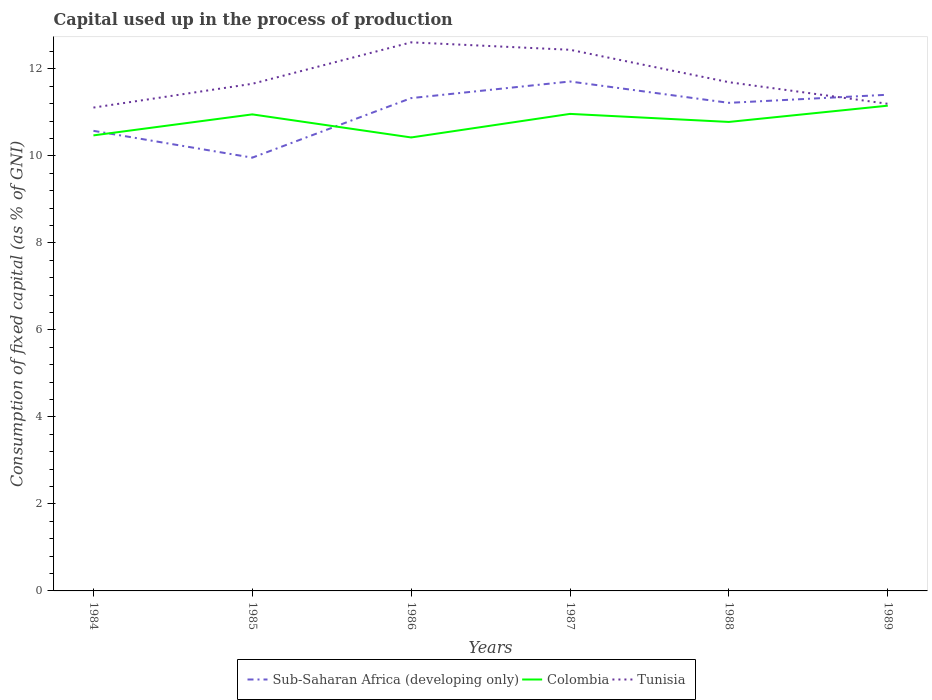Does the line corresponding to Tunisia intersect with the line corresponding to Sub-Saharan Africa (developing only)?
Offer a very short reply. Yes. Across all years, what is the maximum capital used up in the process of production in Tunisia?
Give a very brief answer. 11.11. In which year was the capital used up in the process of production in Colombia maximum?
Offer a very short reply. 1986. What is the total capital used up in the process of production in Colombia in the graph?
Keep it short and to the point. -0.19. What is the difference between the highest and the second highest capital used up in the process of production in Sub-Saharan Africa (developing only)?
Give a very brief answer. 1.75. What is the difference between the highest and the lowest capital used up in the process of production in Sub-Saharan Africa (developing only)?
Your answer should be very brief. 4. Is the capital used up in the process of production in Tunisia strictly greater than the capital used up in the process of production in Colombia over the years?
Offer a terse response. No. Are the values on the major ticks of Y-axis written in scientific E-notation?
Provide a short and direct response. No. What is the title of the graph?
Your answer should be compact. Capital used up in the process of production. What is the label or title of the X-axis?
Offer a very short reply. Years. What is the label or title of the Y-axis?
Offer a very short reply. Consumption of fixed capital (as % of GNI). What is the Consumption of fixed capital (as % of GNI) of Sub-Saharan Africa (developing only) in 1984?
Offer a very short reply. 10.58. What is the Consumption of fixed capital (as % of GNI) in Colombia in 1984?
Offer a very short reply. 10.47. What is the Consumption of fixed capital (as % of GNI) in Tunisia in 1984?
Make the answer very short. 11.11. What is the Consumption of fixed capital (as % of GNI) of Sub-Saharan Africa (developing only) in 1985?
Make the answer very short. 9.96. What is the Consumption of fixed capital (as % of GNI) in Colombia in 1985?
Offer a terse response. 10.96. What is the Consumption of fixed capital (as % of GNI) in Tunisia in 1985?
Keep it short and to the point. 11.66. What is the Consumption of fixed capital (as % of GNI) of Sub-Saharan Africa (developing only) in 1986?
Your answer should be compact. 11.33. What is the Consumption of fixed capital (as % of GNI) in Colombia in 1986?
Your answer should be very brief. 10.43. What is the Consumption of fixed capital (as % of GNI) in Tunisia in 1986?
Ensure brevity in your answer.  12.61. What is the Consumption of fixed capital (as % of GNI) in Sub-Saharan Africa (developing only) in 1987?
Give a very brief answer. 11.71. What is the Consumption of fixed capital (as % of GNI) of Colombia in 1987?
Your answer should be compact. 10.97. What is the Consumption of fixed capital (as % of GNI) in Tunisia in 1987?
Provide a succinct answer. 12.44. What is the Consumption of fixed capital (as % of GNI) in Sub-Saharan Africa (developing only) in 1988?
Your answer should be compact. 11.22. What is the Consumption of fixed capital (as % of GNI) in Colombia in 1988?
Provide a short and direct response. 10.78. What is the Consumption of fixed capital (as % of GNI) in Tunisia in 1988?
Provide a short and direct response. 11.7. What is the Consumption of fixed capital (as % of GNI) in Sub-Saharan Africa (developing only) in 1989?
Your response must be concise. 11.41. What is the Consumption of fixed capital (as % of GNI) in Colombia in 1989?
Keep it short and to the point. 11.16. What is the Consumption of fixed capital (as % of GNI) of Tunisia in 1989?
Ensure brevity in your answer.  11.2. Across all years, what is the maximum Consumption of fixed capital (as % of GNI) in Sub-Saharan Africa (developing only)?
Your answer should be compact. 11.71. Across all years, what is the maximum Consumption of fixed capital (as % of GNI) in Colombia?
Your answer should be compact. 11.16. Across all years, what is the maximum Consumption of fixed capital (as % of GNI) of Tunisia?
Your answer should be very brief. 12.61. Across all years, what is the minimum Consumption of fixed capital (as % of GNI) in Sub-Saharan Africa (developing only)?
Your answer should be compact. 9.96. Across all years, what is the minimum Consumption of fixed capital (as % of GNI) in Colombia?
Provide a succinct answer. 10.43. Across all years, what is the minimum Consumption of fixed capital (as % of GNI) of Tunisia?
Offer a very short reply. 11.11. What is the total Consumption of fixed capital (as % of GNI) in Sub-Saharan Africa (developing only) in the graph?
Offer a terse response. 66.21. What is the total Consumption of fixed capital (as % of GNI) in Colombia in the graph?
Your answer should be very brief. 64.76. What is the total Consumption of fixed capital (as % of GNI) in Tunisia in the graph?
Make the answer very short. 70.72. What is the difference between the Consumption of fixed capital (as % of GNI) of Sub-Saharan Africa (developing only) in 1984 and that in 1985?
Your answer should be compact. 0.62. What is the difference between the Consumption of fixed capital (as % of GNI) in Colombia in 1984 and that in 1985?
Provide a short and direct response. -0.48. What is the difference between the Consumption of fixed capital (as % of GNI) of Tunisia in 1984 and that in 1985?
Your answer should be very brief. -0.55. What is the difference between the Consumption of fixed capital (as % of GNI) of Sub-Saharan Africa (developing only) in 1984 and that in 1986?
Ensure brevity in your answer.  -0.75. What is the difference between the Consumption of fixed capital (as % of GNI) in Colombia in 1984 and that in 1986?
Your answer should be very brief. 0.05. What is the difference between the Consumption of fixed capital (as % of GNI) of Tunisia in 1984 and that in 1986?
Make the answer very short. -1.5. What is the difference between the Consumption of fixed capital (as % of GNI) of Sub-Saharan Africa (developing only) in 1984 and that in 1987?
Ensure brevity in your answer.  -1.13. What is the difference between the Consumption of fixed capital (as % of GNI) in Colombia in 1984 and that in 1987?
Your response must be concise. -0.49. What is the difference between the Consumption of fixed capital (as % of GNI) of Tunisia in 1984 and that in 1987?
Offer a terse response. -1.33. What is the difference between the Consumption of fixed capital (as % of GNI) of Sub-Saharan Africa (developing only) in 1984 and that in 1988?
Offer a terse response. -0.64. What is the difference between the Consumption of fixed capital (as % of GNI) of Colombia in 1984 and that in 1988?
Provide a short and direct response. -0.31. What is the difference between the Consumption of fixed capital (as % of GNI) in Tunisia in 1984 and that in 1988?
Your response must be concise. -0.58. What is the difference between the Consumption of fixed capital (as % of GNI) of Sub-Saharan Africa (developing only) in 1984 and that in 1989?
Give a very brief answer. -0.83. What is the difference between the Consumption of fixed capital (as % of GNI) of Colombia in 1984 and that in 1989?
Give a very brief answer. -0.68. What is the difference between the Consumption of fixed capital (as % of GNI) in Tunisia in 1984 and that in 1989?
Make the answer very short. -0.09. What is the difference between the Consumption of fixed capital (as % of GNI) in Sub-Saharan Africa (developing only) in 1985 and that in 1986?
Your answer should be very brief. -1.37. What is the difference between the Consumption of fixed capital (as % of GNI) of Colombia in 1985 and that in 1986?
Ensure brevity in your answer.  0.53. What is the difference between the Consumption of fixed capital (as % of GNI) in Tunisia in 1985 and that in 1986?
Provide a short and direct response. -0.95. What is the difference between the Consumption of fixed capital (as % of GNI) in Sub-Saharan Africa (developing only) in 1985 and that in 1987?
Ensure brevity in your answer.  -1.75. What is the difference between the Consumption of fixed capital (as % of GNI) in Colombia in 1985 and that in 1987?
Give a very brief answer. -0.01. What is the difference between the Consumption of fixed capital (as % of GNI) in Tunisia in 1985 and that in 1987?
Offer a very short reply. -0.78. What is the difference between the Consumption of fixed capital (as % of GNI) of Sub-Saharan Africa (developing only) in 1985 and that in 1988?
Give a very brief answer. -1.26. What is the difference between the Consumption of fixed capital (as % of GNI) of Colombia in 1985 and that in 1988?
Your answer should be compact. 0.17. What is the difference between the Consumption of fixed capital (as % of GNI) of Tunisia in 1985 and that in 1988?
Provide a succinct answer. -0.04. What is the difference between the Consumption of fixed capital (as % of GNI) in Sub-Saharan Africa (developing only) in 1985 and that in 1989?
Make the answer very short. -1.45. What is the difference between the Consumption of fixed capital (as % of GNI) of Colombia in 1985 and that in 1989?
Give a very brief answer. -0.2. What is the difference between the Consumption of fixed capital (as % of GNI) of Tunisia in 1985 and that in 1989?
Your answer should be compact. 0.46. What is the difference between the Consumption of fixed capital (as % of GNI) in Sub-Saharan Africa (developing only) in 1986 and that in 1987?
Provide a short and direct response. -0.38. What is the difference between the Consumption of fixed capital (as % of GNI) in Colombia in 1986 and that in 1987?
Provide a succinct answer. -0.54. What is the difference between the Consumption of fixed capital (as % of GNI) of Tunisia in 1986 and that in 1987?
Offer a very short reply. 0.17. What is the difference between the Consumption of fixed capital (as % of GNI) in Sub-Saharan Africa (developing only) in 1986 and that in 1988?
Offer a very short reply. 0.11. What is the difference between the Consumption of fixed capital (as % of GNI) in Colombia in 1986 and that in 1988?
Give a very brief answer. -0.36. What is the difference between the Consumption of fixed capital (as % of GNI) in Tunisia in 1986 and that in 1988?
Offer a very short reply. 0.92. What is the difference between the Consumption of fixed capital (as % of GNI) of Sub-Saharan Africa (developing only) in 1986 and that in 1989?
Your answer should be compact. -0.08. What is the difference between the Consumption of fixed capital (as % of GNI) in Colombia in 1986 and that in 1989?
Offer a very short reply. -0.73. What is the difference between the Consumption of fixed capital (as % of GNI) in Tunisia in 1986 and that in 1989?
Provide a succinct answer. 1.41. What is the difference between the Consumption of fixed capital (as % of GNI) of Sub-Saharan Africa (developing only) in 1987 and that in 1988?
Give a very brief answer. 0.49. What is the difference between the Consumption of fixed capital (as % of GNI) in Colombia in 1987 and that in 1988?
Your response must be concise. 0.18. What is the difference between the Consumption of fixed capital (as % of GNI) of Tunisia in 1987 and that in 1988?
Provide a succinct answer. 0.75. What is the difference between the Consumption of fixed capital (as % of GNI) in Sub-Saharan Africa (developing only) in 1987 and that in 1989?
Provide a short and direct response. 0.3. What is the difference between the Consumption of fixed capital (as % of GNI) of Colombia in 1987 and that in 1989?
Offer a very short reply. -0.19. What is the difference between the Consumption of fixed capital (as % of GNI) in Tunisia in 1987 and that in 1989?
Your response must be concise. 1.24. What is the difference between the Consumption of fixed capital (as % of GNI) in Sub-Saharan Africa (developing only) in 1988 and that in 1989?
Ensure brevity in your answer.  -0.19. What is the difference between the Consumption of fixed capital (as % of GNI) of Colombia in 1988 and that in 1989?
Offer a very short reply. -0.37. What is the difference between the Consumption of fixed capital (as % of GNI) in Tunisia in 1988 and that in 1989?
Make the answer very short. 0.5. What is the difference between the Consumption of fixed capital (as % of GNI) of Sub-Saharan Africa (developing only) in 1984 and the Consumption of fixed capital (as % of GNI) of Colombia in 1985?
Your answer should be very brief. -0.38. What is the difference between the Consumption of fixed capital (as % of GNI) in Sub-Saharan Africa (developing only) in 1984 and the Consumption of fixed capital (as % of GNI) in Tunisia in 1985?
Your answer should be compact. -1.08. What is the difference between the Consumption of fixed capital (as % of GNI) in Colombia in 1984 and the Consumption of fixed capital (as % of GNI) in Tunisia in 1985?
Make the answer very short. -1.19. What is the difference between the Consumption of fixed capital (as % of GNI) in Sub-Saharan Africa (developing only) in 1984 and the Consumption of fixed capital (as % of GNI) in Colombia in 1986?
Make the answer very short. 0.15. What is the difference between the Consumption of fixed capital (as % of GNI) of Sub-Saharan Africa (developing only) in 1984 and the Consumption of fixed capital (as % of GNI) of Tunisia in 1986?
Provide a succinct answer. -2.03. What is the difference between the Consumption of fixed capital (as % of GNI) in Colombia in 1984 and the Consumption of fixed capital (as % of GNI) in Tunisia in 1986?
Make the answer very short. -2.14. What is the difference between the Consumption of fixed capital (as % of GNI) in Sub-Saharan Africa (developing only) in 1984 and the Consumption of fixed capital (as % of GNI) in Colombia in 1987?
Your response must be concise. -0.39. What is the difference between the Consumption of fixed capital (as % of GNI) of Sub-Saharan Africa (developing only) in 1984 and the Consumption of fixed capital (as % of GNI) of Tunisia in 1987?
Keep it short and to the point. -1.86. What is the difference between the Consumption of fixed capital (as % of GNI) of Colombia in 1984 and the Consumption of fixed capital (as % of GNI) of Tunisia in 1987?
Make the answer very short. -1.97. What is the difference between the Consumption of fixed capital (as % of GNI) of Sub-Saharan Africa (developing only) in 1984 and the Consumption of fixed capital (as % of GNI) of Colombia in 1988?
Provide a succinct answer. -0.2. What is the difference between the Consumption of fixed capital (as % of GNI) of Sub-Saharan Africa (developing only) in 1984 and the Consumption of fixed capital (as % of GNI) of Tunisia in 1988?
Make the answer very short. -1.12. What is the difference between the Consumption of fixed capital (as % of GNI) in Colombia in 1984 and the Consumption of fixed capital (as % of GNI) in Tunisia in 1988?
Ensure brevity in your answer.  -1.22. What is the difference between the Consumption of fixed capital (as % of GNI) of Sub-Saharan Africa (developing only) in 1984 and the Consumption of fixed capital (as % of GNI) of Colombia in 1989?
Ensure brevity in your answer.  -0.58. What is the difference between the Consumption of fixed capital (as % of GNI) of Sub-Saharan Africa (developing only) in 1984 and the Consumption of fixed capital (as % of GNI) of Tunisia in 1989?
Offer a terse response. -0.62. What is the difference between the Consumption of fixed capital (as % of GNI) in Colombia in 1984 and the Consumption of fixed capital (as % of GNI) in Tunisia in 1989?
Offer a terse response. -0.73. What is the difference between the Consumption of fixed capital (as % of GNI) of Sub-Saharan Africa (developing only) in 1985 and the Consumption of fixed capital (as % of GNI) of Colombia in 1986?
Offer a very short reply. -0.46. What is the difference between the Consumption of fixed capital (as % of GNI) of Sub-Saharan Africa (developing only) in 1985 and the Consumption of fixed capital (as % of GNI) of Tunisia in 1986?
Make the answer very short. -2.65. What is the difference between the Consumption of fixed capital (as % of GNI) in Colombia in 1985 and the Consumption of fixed capital (as % of GNI) in Tunisia in 1986?
Your response must be concise. -1.66. What is the difference between the Consumption of fixed capital (as % of GNI) in Sub-Saharan Africa (developing only) in 1985 and the Consumption of fixed capital (as % of GNI) in Colombia in 1987?
Provide a short and direct response. -1.01. What is the difference between the Consumption of fixed capital (as % of GNI) of Sub-Saharan Africa (developing only) in 1985 and the Consumption of fixed capital (as % of GNI) of Tunisia in 1987?
Make the answer very short. -2.48. What is the difference between the Consumption of fixed capital (as % of GNI) in Colombia in 1985 and the Consumption of fixed capital (as % of GNI) in Tunisia in 1987?
Offer a terse response. -1.49. What is the difference between the Consumption of fixed capital (as % of GNI) in Sub-Saharan Africa (developing only) in 1985 and the Consumption of fixed capital (as % of GNI) in Colombia in 1988?
Offer a terse response. -0.82. What is the difference between the Consumption of fixed capital (as % of GNI) in Sub-Saharan Africa (developing only) in 1985 and the Consumption of fixed capital (as % of GNI) in Tunisia in 1988?
Give a very brief answer. -1.73. What is the difference between the Consumption of fixed capital (as % of GNI) of Colombia in 1985 and the Consumption of fixed capital (as % of GNI) of Tunisia in 1988?
Your answer should be compact. -0.74. What is the difference between the Consumption of fixed capital (as % of GNI) of Sub-Saharan Africa (developing only) in 1985 and the Consumption of fixed capital (as % of GNI) of Colombia in 1989?
Your response must be concise. -1.2. What is the difference between the Consumption of fixed capital (as % of GNI) in Sub-Saharan Africa (developing only) in 1985 and the Consumption of fixed capital (as % of GNI) in Tunisia in 1989?
Your answer should be very brief. -1.24. What is the difference between the Consumption of fixed capital (as % of GNI) in Colombia in 1985 and the Consumption of fixed capital (as % of GNI) in Tunisia in 1989?
Your response must be concise. -0.24. What is the difference between the Consumption of fixed capital (as % of GNI) of Sub-Saharan Africa (developing only) in 1986 and the Consumption of fixed capital (as % of GNI) of Colombia in 1987?
Give a very brief answer. 0.36. What is the difference between the Consumption of fixed capital (as % of GNI) in Sub-Saharan Africa (developing only) in 1986 and the Consumption of fixed capital (as % of GNI) in Tunisia in 1987?
Provide a short and direct response. -1.11. What is the difference between the Consumption of fixed capital (as % of GNI) in Colombia in 1986 and the Consumption of fixed capital (as % of GNI) in Tunisia in 1987?
Your answer should be compact. -2.02. What is the difference between the Consumption of fixed capital (as % of GNI) in Sub-Saharan Africa (developing only) in 1986 and the Consumption of fixed capital (as % of GNI) in Colombia in 1988?
Make the answer very short. 0.55. What is the difference between the Consumption of fixed capital (as % of GNI) of Sub-Saharan Africa (developing only) in 1986 and the Consumption of fixed capital (as % of GNI) of Tunisia in 1988?
Give a very brief answer. -0.37. What is the difference between the Consumption of fixed capital (as % of GNI) in Colombia in 1986 and the Consumption of fixed capital (as % of GNI) in Tunisia in 1988?
Provide a short and direct response. -1.27. What is the difference between the Consumption of fixed capital (as % of GNI) of Sub-Saharan Africa (developing only) in 1986 and the Consumption of fixed capital (as % of GNI) of Colombia in 1989?
Give a very brief answer. 0.17. What is the difference between the Consumption of fixed capital (as % of GNI) of Sub-Saharan Africa (developing only) in 1986 and the Consumption of fixed capital (as % of GNI) of Tunisia in 1989?
Your response must be concise. 0.13. What is the difference between the Consumption of fixed capital (as % of GNI) of Colombia in 1986 and the Consumption of fixed capital (as % of GNI) of Tunisia in 1989?
Keep it short and to the point. -0.77. What is the difference between the Consumption of fixed capital (as % of GNI) of Sub-Saharan Africa (developing only) in 1987 and the Consumption of fixed capital (as % of GNI) of Colombia in 1988?
Your response must be concise. 0.93. What is the difference between the Consumption of fixed capital (as % of GNI) in Sub-Saharan Africa (developing only) in 1987 and the Consumption of fixed capital (as % of GNI) in Tunisia in 1988?
Your answer should be compact. 0.02. What is the difference between the Consumption of fixed capital (as % of GNI) of Colombia in 1987 and the Consumption of fixed capital (as % of GNI) of Tunisia in 1988?
Give a very brief answer. -0.73. What is the difference between the Consumption of fixed capital (as % of GNI) in Sub-Saharan Africa (developing only) in 1987 and the Consumption of fixed capital (as % of GNI) in Colombia in 1989?
Offer a terse response. 0.56. What is the difference between the Consumption of fixed capital (as % of GNI) of Sub-Saharan Africa (developing only) in 1987 and the Consumption of fixed capital (as % of GNI) of Tunisia in 1989?
Your answer should be very brief. 0.51. What is the difference between the Consumption of fixed capital (as % of GNI) in Colombia in 1987 and the Consumption of fixed capital (as % of GNI) in Tunisia in 1989?
Provide a short and direct response. -0.23. What is the difference between the Consumption of fixed capital (as % of GNI) of Sub-Saharan Africa (developing only) in 1988 and the Consumption of fixed capital (as % of GNI) of Colombia in 1989?
Offer a terse response. 0.06. What is the difference between the Consumption of fixed capital (as % of GNI) in Sub-Saharan Africa (developing only) in 1988 and the Consumption of fixed capital (as % of GNI) in Tunisia in 1989?
Keep it short and to the point. 0.02. What is the difference between the Consumption of fixed capital (as % of GNI) of Colombia in 1988 and the Consumption of fixed capital (as % of GNI) of Tunisia in 1989?
Offer a terse response. -0.42. What is the average Consumption of fixed capital (as % of GNI) of Sub-Saharan Africa (developing only) per year?
Your answer should be compact. 11.04. What is the average Consumption of fixed capital (as % of GNI) of Colombia per year?
Offer a terse response. 10.79. What is the average Consumption of fixed capital (as % of GNI) in Tunisia per year?
Give a very brief answer. 11.79. In the year 1984, what is the difference between the Consumption of fixed capital (as % of GNI) in Sub-Saharan Africa (developing only) and Consumption of fixed capital (as % of GNI) in Colombia?
Your answer should be very brief. 0.1. In the year 1984, what is the difference between the Consumption of fixed capital (as % of GNI) in Sub-Saharan Africa (developing only) and Consumption of fixed capital (as % of GNI) in Tunisia?
Keep it short and to the point. -0.53. In the year 1984, what is the difference between the Consumption of fixed capital (as % of GNI) in Colombia and Consumption of fixed capital (as % of GNI) in Tunisia?
Give a very brief answer. -0.64. In the year 1985, what is the difference between the Consumption of fixed capital (as % of GNI) in Sub-Saharan Africa (developing only) and Consumption of fixed capital (as % of GNI) in Colombia?
Give a very brief answer. -0.99. In the year 1985, what is the difference between the Consumption of fixed capital (as % of GNI) of Sub-Saharan Africa (developing only) and Consumption of fixed capital (as % of GNI) of Tunisia?
Your response must be concise. -1.7. In the year 1985, what is the difference between the Consumption of fixed capital (as % of GNI) in Colombia and Consumption of fixed capital (as % of GNI) in Tunisia?
Ensure brevity in your answer.  -0.7. In the year 1986, what is the difference between the Consumption of fixed capital (as % of GNI) of Sub-Saharan Africa (developing only) and Consumption of fixed capital (as % of GNI) of Colombia?
Keep it short and to the point. 0.9. In the year 1986, what is the difference between the Consumption of fixed capital (as % of GNI) in Sub-Saharan Africa (developing only) and Consumption of fixed capital (as % of GNI) in Tunisia?
Your response must be concise. -1.28. In the year 1986, what is the difference between the Consumption of fixed capital (as % of GNI) of Colombia and Consumption of fixed capital (as % of GNI) of Tunisia?
Your answer should be compact. -2.19. In the year 1987, what is the difference between the Consumption of fixed capital (as % of GNI) of Sub-Saharan Africa (developing only) and Consumption of fixed capital (as % of GNI) of Colombia?
Give a very brief answer. 0.74. In the year 1987, what is the difference between the Consumption of fixed capital (as % of GNI) in Sub-Saharan Africa (developing only) and Consumption of fixed capital (as % of GNI) in Tunisia?
Your response must be concise. -0.73. In the year 1987, what is the difference between the Consumption of fixed capital (as % of GNI) in Colombia and Consumption of fixed capital (as % of GNI) in Tunisia?
Offer a very short reply. -1.47. In the year 1988, what is the difference between the Consumption of fixed capital (as % of GNI) in Sub-Saharan Africa (developing only) and Consumption of fixed capital (as % of GNI) in Colombia?
Your answer should be very brief. 0.44. In the year 1988, what is the difference between the Consumption of fixed capital (as % of GNI) in Sub-Saharan Africa (developing only) and Consumption of fixed capital (as % of GNI) in Tunisia?
Offer a terse response. -0.47. In the year 1988, what is the difference between the Consumption of fixed capital (as % of GNI) in Colombia and Consumption of fixed capital (as % of GNI) in Tunisia?
Your answer should be very brief. -0.91. In the year 1989, what is the difference between the Consumption of fixed capital (as % of GNI) in Sub-Saharan Africa (developing only) and Consumption of fixed capital (as % of GNI) in Colombia?
Provide a short and direct response. 0.25. In the year 1989, what is the difference between the Consumption of fixed capital (as % of GNI) of Sub-Saharan Africa (developing only) and Consumption of fixed capital (as % of GNI) of Tunisia?
Your answer should be very brief. 0.21. In the year 1989, what is the difference between the Consumption of fixed capital (as % of GNI) of Colombia and Consumption of fixed capital (as % of GNI) of Tunisia?
Give a very brief answer. -0.04. What is the ratio of the Consumption of fixed capital (as % of GNI) in Sub-Saharan Africa (developing only) in 1984 to that in 1985?
Your answer should be compact. 1.06. What is the ratio of the Consumption of fixed capital (as % of GNI) of Colombia in 1984 to that in 1985?
Make the answer very short. 0.96. What is the ratio of the Consumption of fixed capital (as % of GNI) of Tunisia in 1984 to that in 1985?
Provide a short and direct response. 0.95. What is the ratio of the Consumption of fixed capital (as % of GNI) of Sub-Saharan Africa (developing only) in 1984 to that in 1986?
Offer a terse response. 0.93. What is the ratio of the Consumption of fixed capital (as % of GNI) in Tunisia in 1984 to that in 1986?
Provide a short and direct response. 0.88. What is the ratio of the Consumption of fixed capital (as % of GNI) in Sub-Saharan Africa (developing only) in 1984 to that in 1987?
Offer a very short reply. 0.9. What is the ratio of the Consumption of fixed capital (as % of GNI) in Colombia in 1984 to that in 1987?
Offer a very short reply. 0.95. What is the ratio of the Consumption of fixed capital (as % of GNI) of Tunisia in 1984 to that in 1987?
Keep it short and to the point. 0.89. What is the ratio of the Consumption of fixed capital (as % of GNI) in Sub-Saharan Africa (developing only) in 1984 to that in 1988?
Your answer should be very brief. 0.94. What is the ratio of the Consumption of fixed capital (as % of GNI) in Colombia in 1984 to that in 1988?
Keep it short and to the point. 0.97. What is the ratio of the Consumption of fixed capital (as % of GNI) of Tunisia in 1984 to that in 1988?
Your response must be concise. 0.95. What is the ratio of the Consumption of fixed capital (as % of GNI) in Sub-Saharan Africa (developing only) in 1984 to that in 1989?
Ensure brevity in your answer.  0.93. What is the ratio of the Consumption of fixed capital (as % of GNI) in Colombia in 1984 to that in 1989?
Offer a very short reply. 0.94. What is the ratio of the Consumption of fixed capital (as % of GNI) in Sub-Saharan Africa (developing only) in 1985 to that in 1986?
Provide a short and direct response. 0.88. What is the ratio of the Consumption of fixed capital (as % of GNI) of Colombia in 1985 to that in 1986?
Provide a short and direct response. 1.05. What is the ratio of the Consumption of fixed capital (as % of GNI) in Tunisia in 1985 to that in 1986?
Ensure brevity in your answer.  0.92. What is the ratio of the Consumption of fixed capital (as % of GNI) of Sub-Saharan Africa (developing only) in 1985 to that in 1987?
Offer a terse response. 0.85. What is the ratio of the Consumption of fixed capital (as % of GNI) of Colombia in 1985 to that in 1987?
Keep it short and to the point. 1. What is the ratio of the Consumption of fixed capital (as % of GNI) in Tunisia in 1985 to that in 1987?
Your answer should be very brief. 0.94. What is the ratio of the Consumption of fixed capital (as % of GNI) in Sub-Saharan Africa (developing only) in 1985 to that in 1988?
Offer a very short reply. 0.89. What is the ratio of the Consumption of fixed capital (as % of GNI) of Colombia in 1985 to that in 1988?
Provide a succinct answer. 1.02. What is the ratio of the Consumption of fixed capital (as % of GNI) of Tunisia in 1985 to that in 1988?
Your response must be concise. 1. What is the ratio of the Consumption of fixed capital (as % of GNI) of Sub-Saharan Africa (developing only) in 1985 to that in 1989?
Ensure brevity in your answer.  0.87. What is the ratio of the Consumption of fixed capital (as % of GNI) in Tunisia in 1985 to that in 1989?
Offer a terse response. 1.04. What is the ratio of the Consumption of fixed capital (as % of GNI) in Sub-Saharan Africa (developing only) in 1986 to that in 1987?
Provide a succinct answer. 0.97. What is the ratio of the Consumption of fixed capital (as % of GNI) in Colombia in 1986 to that in 1987?
Provide a short and direct response. 0.95. What is the ratio of the Consumption of fixed capital (as % of GNI) in Tunisia in 1986 to that in 1987?
Your response must be concise. 1.01. What is the ratio of the Consumption of fixed capital (as % of GNI) of Sub-Saharan Africa (developing only) in 1986 to that in 1988?
Your answer should be very brief. 1.01. What is the ratio of the Consumption of fixed capital (as % of GNI) in Colombia in 1986 to that in 1988?
Offer a very short reply. 0.97. What is the ratio of the Consumption of fixed capital (as % of GNI) in Tunisia in 1986 to that in 1988?
Offer a terse response. 1.08. What is the ratio of the Consumption of fixed capital (as % of GNI) in Sub-Saharan Africa (developing only) in 1986 to that in 1989?
Offer a very short reply. 0.99. What is the ratio of the Consumption of fixed capital (as % of GNI) of Colombia in 1986 to that in 1989?
Your response must be concise. 0.93. What is the ratio of the Consumption of fixed capital (as % of GNI) in Tunisia in 1986 to that in 1989?
Provide a short and direct response. 1.13. What is the ratio of the Consumption of fixed capital (as % of GNI) in Sub-Saharan Africa (developing only) in 1987 to that in 1988?
Give a very brief answer. 1.04. What is the ratio of the Consumption of fixed capital (as % of GNI) in Colombia in 1987 to that in 1988?
Provide a succinct answer. 1.02. What is the ratio of the Consumption of fixed capital (as % of GNI) in Tunisia in 1987 to that in 1988?
Ensure brevity in your answer.  1.06. What is the ratio of the Consumption of fixed capital (as % of GNI) in Sub-Saharan Africa (developing only) in 1987 to that in 1989?
Your response must be concise. 1.03. What is the ratio of the Consumption of fixed capital (as % of GNI) in Colombia in 1987 to that in 1989?
Your response must be concise. 0.98. What is the ratio of the Consumption of fixed capital (as % of GNI) of Tunisia in 1987 to that in 1989?
Your answer should be very brief. 1.11. What is the ratio of the Consumption of fixed capital (as % of GNI) in Sub-Saharan Africa (developing only) in 1988 to that in 1989?
Give a very brief answer. 0.98. What is the ratio of the Consumption of fixed capital (as % of GNI) in Colombia in 1988 to that in 1989?
Provide a succinct answer. 0.97. What is the ratio of the Consumption of fixed capital (as % of GNI) in Tunisia in 1988 to that in 1989?
Provide a short and direct response. 1.04. What is the difference between the highest and the second highest Consumption of fixed capital (as % of GNI) in Sub-Saharan Africa (developing only)?
Your answer should be very brief. 0.3. What is the difference between the highest and the second highest Consumption of fixed capital (as % of GNI) of Colombia?
Offer a terse response. 0.19. What is the difference between the highest and the second highest Consumption of fixed capital (as % of GNI) in Tunisia?
Offer a very short reply. 0.17. What is the difference between the highest and the lowest Consumption of fixed capital (as % of GNI) in Sub-Saharan Africa (developing only)?
Your answer should be compact. 1.75. What is the difference between the highest and the lowest Consumption of fixed capital (as % of GNI) of Colombia?
Provide a short and direct response. 0.73. What is the difference between the highest and the lowest Consumption of fixed capital (as % of GNI) of Tunisia?
Offer a terse response. 1.5. 